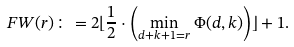<formula> <loc_0><loc_0><loc_500><loc_500>\ F W ( r ) \colon = 2 \lfloor \frac { 1 } { 2 } \cdot \left ( \min _ { d + k + 1 = r } \Phi ( d , k ) \right ) \rfloor + 1 .</formula> 